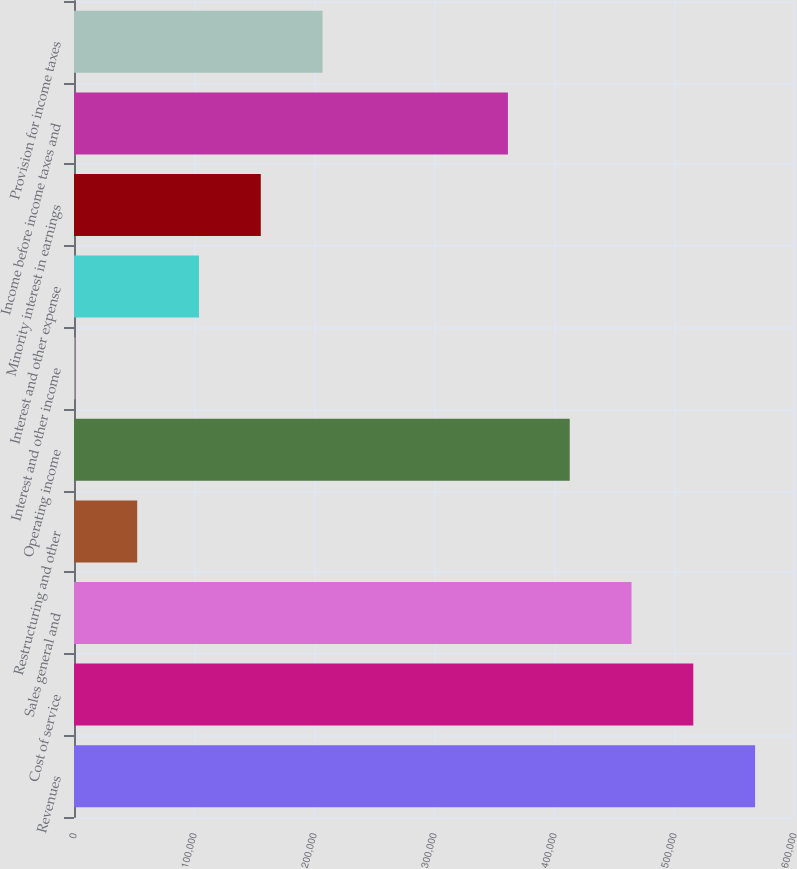Convert chart. <chart><loc_0><loc_0><loc_500><loc_500><bar_chart><fcel>Revenues<fcel>Cost of service<fcel>Sales general and<fcel>Restructuring and other<fcel>Operating income<fcel>Interest and other income<fcel>Interest and other expense<fcel>Minority interest in earnings<fcel>Income before income taxes and<fcel>Provision for income taxes<nl><fcel>567574<fcel>516084<fcel>464594<fcel>52673.1<fcel>413104<fcel>1183<fcel>104163<fcel>155653<fcel>361614<fcel>207143<nl></chart> 